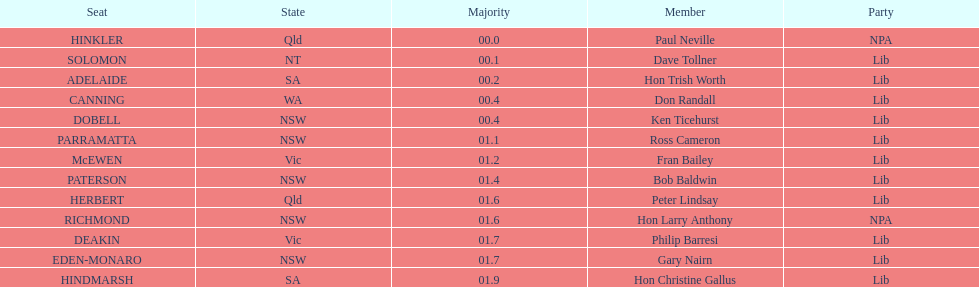What is the overall count of seats? 13. 